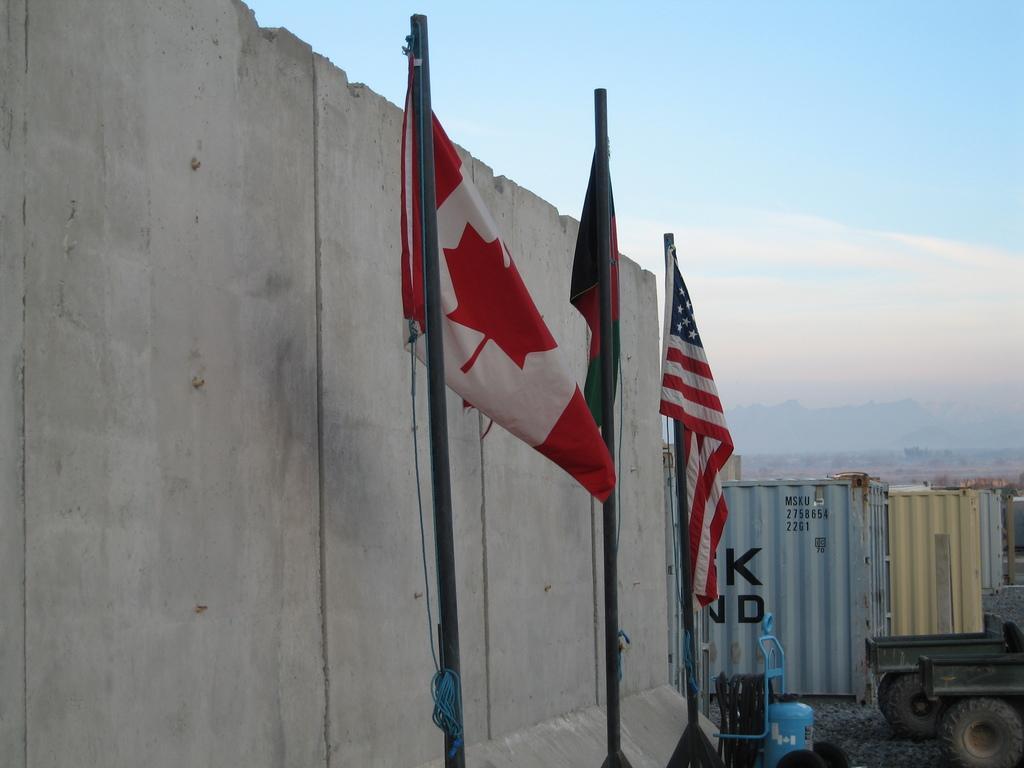Please provide a concise description of this image. In this picture we can see there are poles with flags. On the left side of the flags there is a wall and on the right side of the flags there are some vehicles and it looks like a cylinder shape object. Behind the flags there are containers and the sky. 